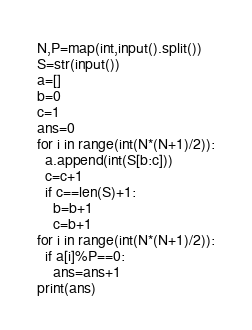<code> <loc_0><loc_0><loc_500><loc_500><_Python_>N,P=map(int,input().split())
S=str(input())
a=[]
b=0
c=1
ans=0
for i in range(int(N*(N+1)/2)):
  a.append(int(S[b:c]))
  c=c+1
  if c==len(S)+1:
    b=b+1
    c=b+1
for i in range(int(N*(N+1)/2)):
  if a[i]%P==0:
    ans=ans+1
print(ans)</code> 